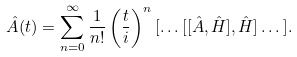Convert formula to latex. <formula><loc_0><loc_0><loc_500><loc_500>\hat { A } ( t ) = \sum _ { n = 0 } ^ { \infty } \frac { 1 } { n ! } \left ( { \frac { t } { i } } \right ) ^ { n } [ \dots [ [ \hat { A } , \hat { H } ] , \hat { H } ] \dots ] .</formula> 